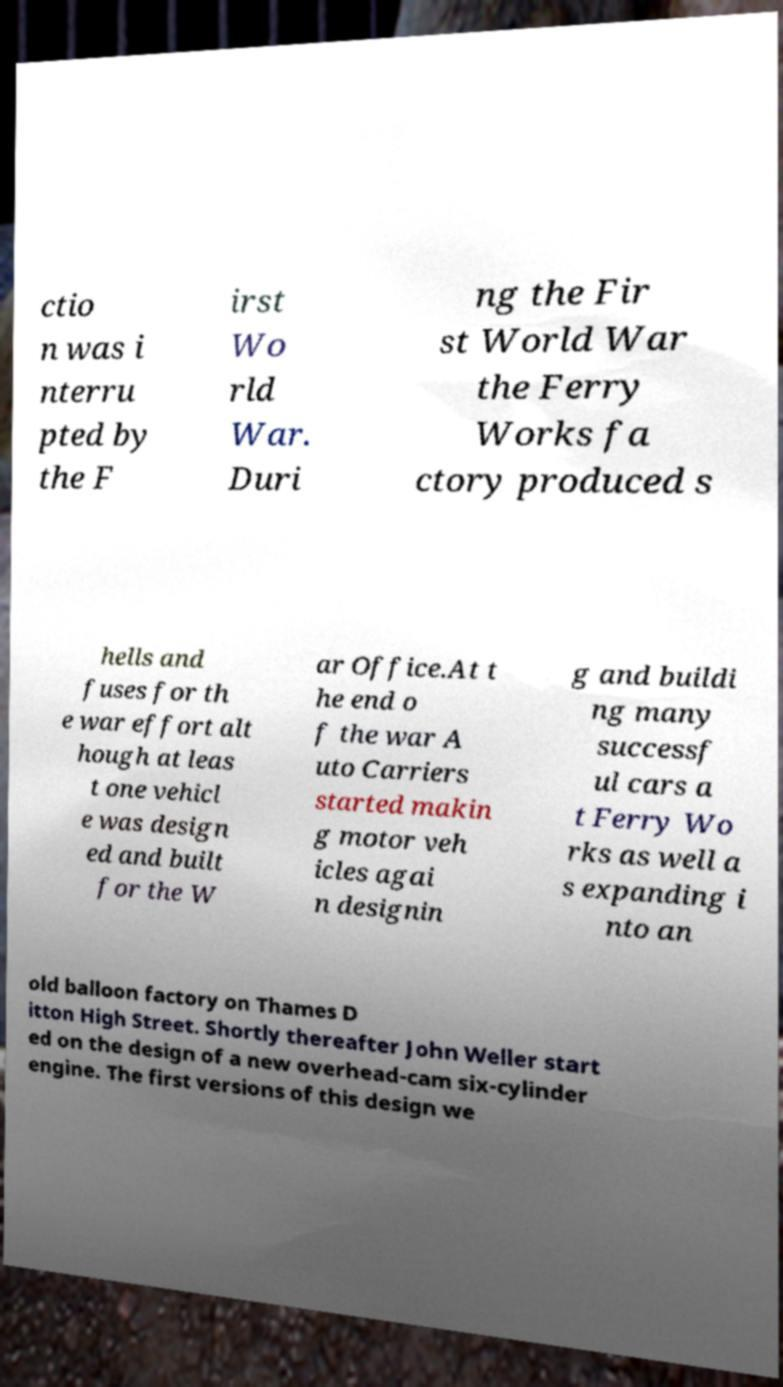Please read and relay the text visible in this image. What does it say? ctio n was i nterru pted by the F irst Wo rld War. Duri ng the Fir st World War the Ferry Works fa ctory produced s hells and fuses for th e war effort alt hough at leas t one vehicl e was design ed and built for the W ar Office.At t he end o f the war A uto Carriers started makin g motor veh icles agai n designin g and buildi ng many successf ul cars a t Ferry Wo rks as well a s expanding i nto an old balloon factory on Thames D itton High Street. Shortly thereafter John Weller start ed on the design of a new overhead-cam six-cylinder engine. The first versions of this design we 